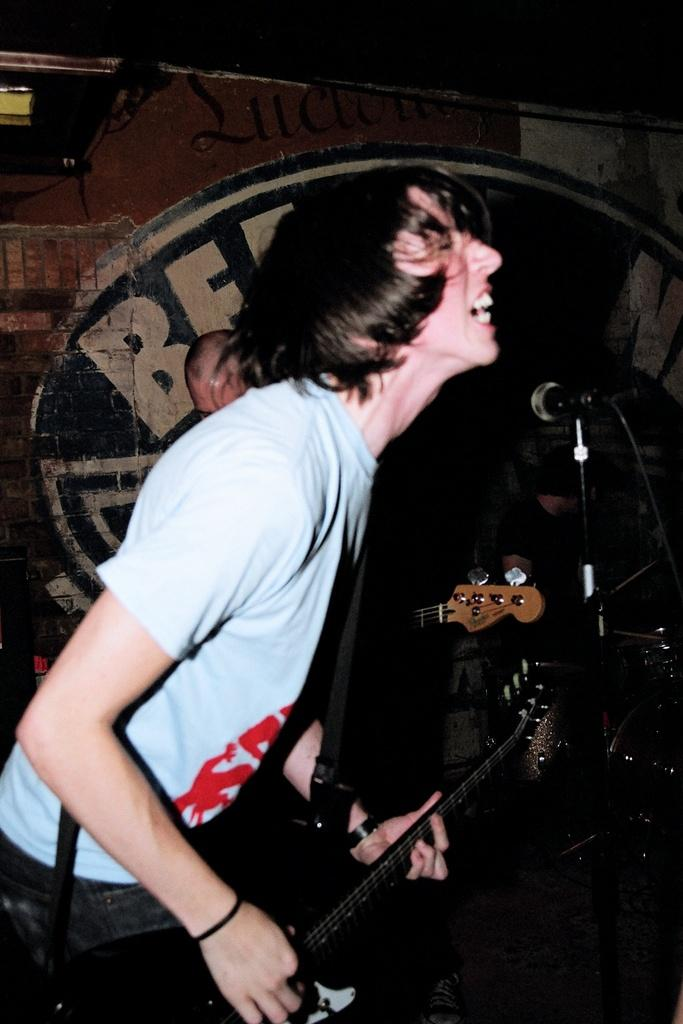What is the person in the image doing? The person is playing a guitar. What object is present in the image that is commonly used for amplifying sound? There is a microphone in the image. Where is the crayon being used in the image? There is no crayon present in the image. What type of town is depicted in the image? The image does not show a town; it features a person playing a guitar and a microphone. 